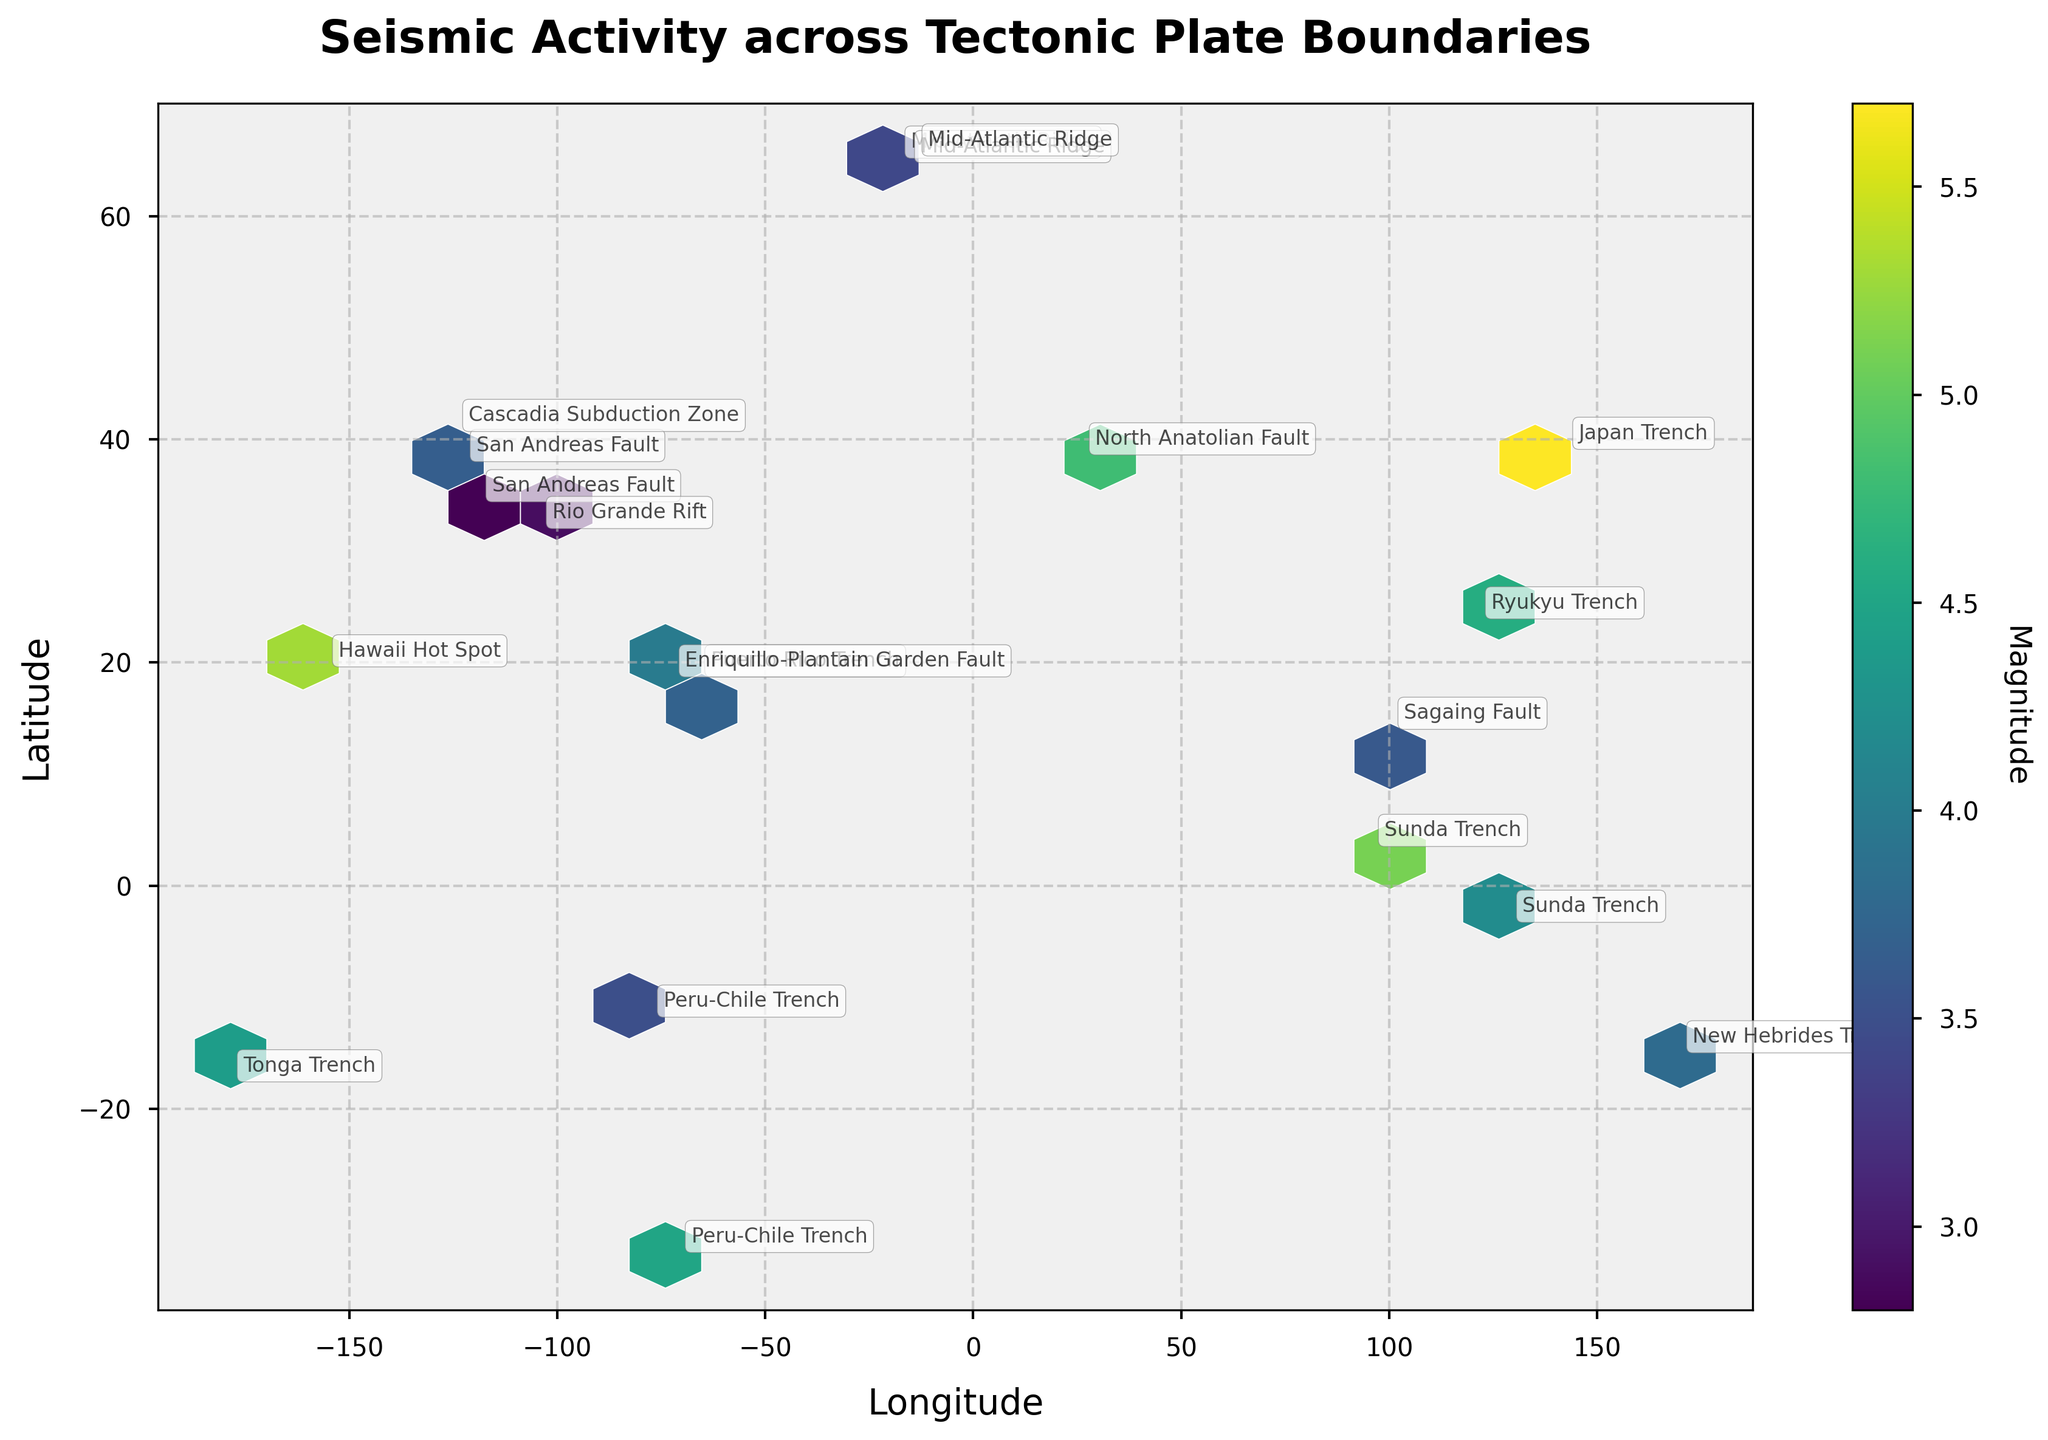What is the title of the plot? The plot's title is the text displayed prominently at the top of the figure. Based on the given code used to generate the plot, the title of this Hexbin Plot is "Seismic Activity across Tectonic Plate Boundaries."
Answer: Seismic Activity across Tectonic Plate Boundaries What are the x and y axis labels? The labels of the x and y axes can be obtained by referring to the text displayed along each axis in the plot. Based on the provided data and code, the x-axis label is "Longitude" and the y-axis label is "Latitude."
Answer: Longitude and Latitude What does the color in the hexbin represent? The color in a hexbin plot usually indicates the magnitude of the aggregated value at each hexagonal bin. In this plot, the color represents the magnitude of seismic activities, as specified by the color bar label "Magnitude."
Answer: Magnitude What is the range of magnitudes represented in the color bar? To understand the range of magnitudes, one should look at the minimum and maximum values on the color bar adjacent to the plot. Based on the magnitudes in the provided data, the range in the color bar should cover from around 2.8 to 5.7.
Answer: Approximately 2.8 to 5.7 Which region has the highest concentration of seismic activities? In a hexbin plot, the region with the highest concentration of seismic activities would have the highest density of hexagonal bins. By observing the plot, we can see which geographic area has the most hexagons. This should be around the Pacific Plate, particularly near the regions affected by the Japan Trench and the Sunda Trench.
Answer: Pacific Plate region (Japan Trench and Sunda Trench) How does the magnitude distribution vary across different tectonic plate boundaries? Reviewing the hexbin color patterns across various tectonic plate boundaries reveals the difference in the magnitude distributions. Regions such as the Japan Trench and Sunda Trench display higher magnitudes (darker color) compared to the Mid-Atlantic Ridge and San Andreas Fault, which exhibit lighter colors.
Answer: Higher magnitudes in Japan Trench and Sunda Trench Compare the seismic activities near the San Andreas Fault and Mid-Atlantic Ridge. To compare the seismic activities, observe both density and magnitude variations in hexagonal bins. The San Andreas Fault appears to have more concentrated activities but of lower magnitudes, while the Mid-Atlantic Ridge shows slightly fewer but moderately strong seizmic activities.
Answer: More concentrated at San Andreas Fault, higher magnitudes in Mid-Atlantic Ridge What is the depth range for seismic activities represented in the plot? Although depth is an attribute contained within the provided data, it is not directly visualized in this hexbin plot. The plot specifically aggregates and colors bins based on magnitude, represented through the color. The depth information is mentioned alongside plate boundaries in the annotation. Therefore, it's between 5.5 km to 45.3 km.
Answer: 5.5 km to 45.3 km Why are some regions annotated with specific tectonic plate boundaries? Regions in the plot are annotated with plate boundaries to help identify the geographical context and specific locations of significant seismic activities. Labels are included for boundary lines where distinct earthquake hubs are observed. This provides a clearer understanding of the locations corresponding to each major tectonic boundary.
Answer: To represent specific locations of seismic activities 